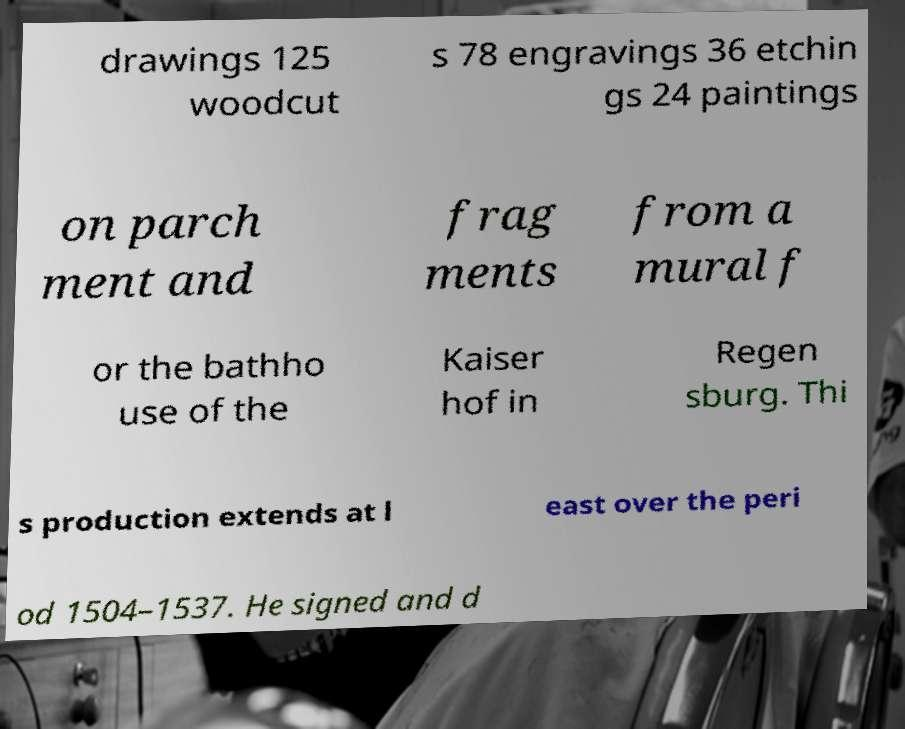There's text embedded in this image that I need extracted. Can you transcribe it verbatim? drawings 125 woodcut s 78 engravings 36 etchin gs 24 paintings on parch ment and frag ments from a mural f or the bathho use of the Kaiser hof in Regen sburg. Thi s production extends at l east over the peri od 1504–1537. He signed and d 